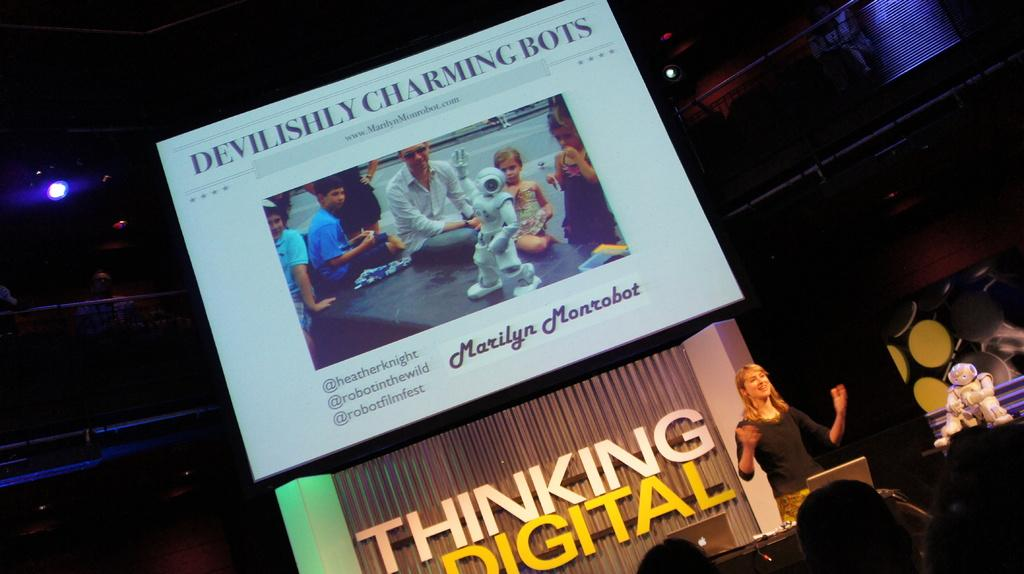<image>
Summarize the visual content of the image. A woman is giving a talk at a Thinking Digital conference. 